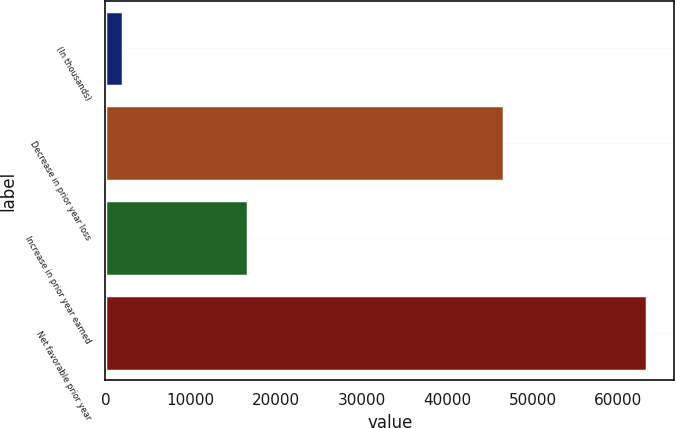Convert chart. <chart><loc_0><loc_0><loc_500><loc_500><bar_chart><fcel>(In thousands)<fcel>Decrease in prior year loss<fcel>Increase in prior year earned<fcel>Net favorable prior year<nl><fcel>2015<fcel>46713<fcel>16730<fcel>63443<nl></chart> 